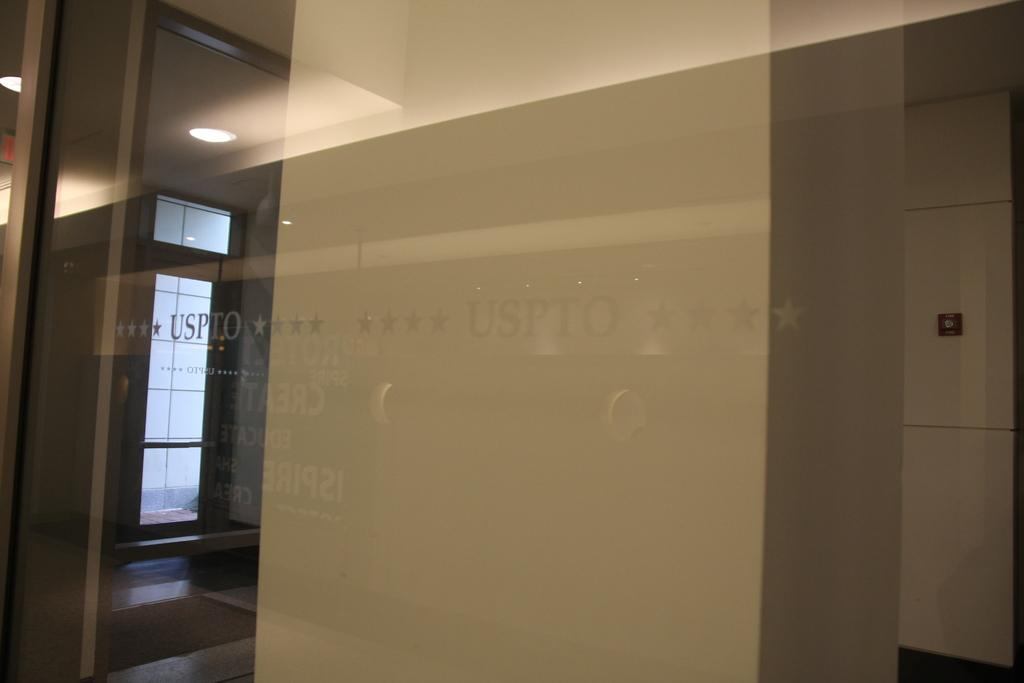What is the main setting of the image? The image is of a room. Can you describe any specific features of the room? There is text on a mirror in the room, and there are lights inside the room. What is attached to the wall in the room? There is an object on the wall in the room. How many lizards can be seen crawling on the wall in the image? There are no lizards present in the image; it is a room with an object on the wall. What type of material is the copper object on the wall made of? There is no mention of copper or any specific material for the object on the wall in the image. 